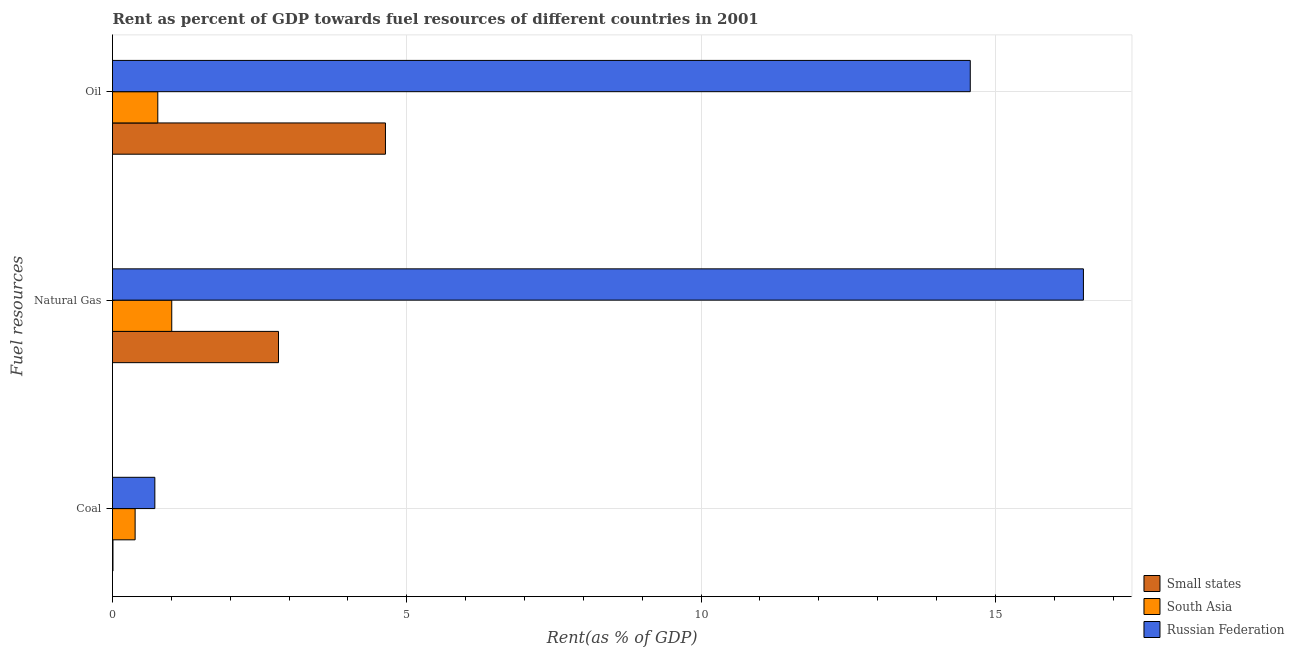How many groups of bars are there?
Make the answer very short. 3. How many bars are there on the 1st tick from the top?
Give a very brief answer. 3. What is the label of the 3rd group of bars from the top?
Provide a succinct answer. Coal. What is the rent towards natural gas in South Asia?
Ensure brevity in your answer.  1.01. Across all countries, what is the maximum rent towards natural gas?
Keep it short and to the point. 16.5. Across all countries, what is the minimum rent towards coal?
Keep it short and to the point. 0.01. In which country was the rent towards oil maximum?
Your answer should be compact. Russian Federation. In which country was the rent towards natural gas minimum?
Offer a terse response. South Asia. What is the total rent towards oil in the graph?
Your answer should be compact. 19.98. What is the difference between the rent towards coal in Small states and that in Russian Federation?
Offer a terse response. -0.71. What is the difference between the rent towards oil in South Asia and the rent towards coal in Russian Federation?
Make the answer very short. 0.05. What is the average rent towards coal per country?
Provide a short and direct response. 0.37. What is the difference between the rent towards natural gas and rent towards oil in Small states?
Provide a short and direct response. -1.82. What is the ratio of the rent towards natural gas in Small states to that in Russian Federation?
Make the answer very short. 0.17. Is the rent towards coal in South Asia less than that in Small states?
Keep it short and to the point. No. Is the difference between the rent towards natural gas in Small states and South Asia greater than the difference between the rent towards coal in Small states and South Asia?
Make the answer very short. Yes. What is the difference between the highest and the second highest rent towards coal?
Ensure brevity in your answer.  0.34. What is the difference between the highest and the lowest rent towards natural gas?
Your answer should be compact. 15.49. What does the 1st bar from the top in Coal represents?
Offer a terse response. Russian Federation. What does the 1st bar from the bottom in Oil represents?
Provide a short and direct response. Small states. Are the values on the major ticks of X-axis written in scientific E-notation?
Make the answer very short. No. Does the graph contain grids?
Keep it short and to the point. Yes. What is the title of the graph?
Keep it short and to the point. Rent as percent of GDP towards fuel resources of different countries in 2001. Does "Tonga" appear as one of the legend labels in the graph?
Your answer should be very brief. No. What is the label or title of the X-axis?
Keep it short and to the point. Rent(as % of GDP). What is the label or title of the Y-axis?
Offer a terse response. Fuel resources. What is the Rent(as % of GDP) in Small states in Coal?
Ensure brevity in your answer.  0.01. What is the Rent(as % of GDP) of South Asia in Coal?
Ensure brevity in your answer.  0.38. What is the Rent(as % of GDP) of Russian Federation in Coal?
Your answer should be compact. 0.72. What is the Rent(as % of GDP) in Small states in Natural Gas?
Make the answer very short. 2.82. What is the Rent(as % of GDP) of South Asia in Natural Gas?
Give a very brief answer. 1.01. What is the Rent(as % of GDP) of Russian Federation in Natural Gas?
Make the answer very short. 16.5. What is the Rent(as % of GDP) in Small states in Oil?
Your response must be concise. 4.64. What is the Rent(as % of GDP) of South Asia in Oil?
Offer a terse response. 0.77. What is the Rent(as % of GDP) in Russian Federation in Oil?
Your answer should be compact. 14.57. Across all Fuel resources, what is the maximum Rent(as % of GDP) of Small states?
Keep it short and to the point. 4.64. Across all Fuel resources, what is the maximum Rent(as % of GDP) in South Asia?
Give a very brief answer. 1.01. Across all Fuel resources, what is the maximum Rent(as % of GDP) of Russian Federation?
Keep it short and to the point. 16.5. Across all Fuel resources, what is the minimum Rent(as % of GDP) in Small states?
Provide a short and direct response. 0.01. Across all Fuel resources, what is the minimum Rent(as % of GDP) of South Asia?
Give a very brief answer. 0.38. Across all Fuel resources, what is the minimum Rent(as % of GDP) of Russian Federation?
Offer a very short reply. 0.72. What is the total Rent(as % of GDP) of Small states in the graph?
Give a very brief answer. 7.47. What is the total Rent(as % of GDP) of South Asia in the graph?
Your answer should be compact. 2.16. What is the total Rent(as % of GDP) in Russian Federation in the graph?
Offer a very short reply. 31.79. What is the difference between the Rent(as % of GDP) of Small states in Coal and that in Natural Gas?
Provide a succinct answer. -2.81. What is the difference between the Rent(as % of GDP) of South Asia in Coal and that in Natural Gas?
Provide a succinct answer. -0.62. What is the difference between the Rent(as % of GDP) of Russian Federation in Coal and that in Natural Gas?
Your answer should be very brief. -15.78. What is the difference between the Rent(as % of GDP) in Small states in Coal and that in Oil?
Keep it short and to the point. -4.63. What is the difference between the Rent(as % of GDP) of South Asia in Coal and that in Oil?
Provide a succinct answer. -0.39. What is the difference between the Rent(as % of GDP) in Russian Federation in Coal and that in Oil?
Your response must be concise. -13.86. What is the difference between the Rent(as % of GDP) in Small states in Natural Gas and that in Oil?
Ensure brevity in your answer.  -1.82. What is the difference between the Rent(as % of GDP) in South Asia in Natural Gas and that in Oil?
Provide a short and direct response. 0.24. What is the difference between the Rent(as % of GDP) in Russian Federation in Natural Gas and that in Oil?
Your response must be concise. 1.92. What is the difference between the Rent(as % of GDP) of Small states in Coal and the Rent(as % of GDP) of South Asia in Natural Gas?
Offer a very short reply. -1. What is the difference between the Rent(as % of GDP) in Small states in Coal and the Rent(as % of GDP) in Russian Federation in Natural Gas?
Your response must be concise. -16.49. What is the difference between the Rent(as % of GDP) in South Asia in Coal and the Rent(as % of GDP) in Russian Federation in Natural Gas?
Provide a short and direct response. -16.11. What is the difference between the Rent(as % of GDP) in Small states in Coal and the Rent(as % of GDP) in South Asia in Oil?
Give a very brief answer. -0.76. What is the difference between the Rent(as % of GDP) of Small states in Coal and the Rent(as % of GDP) of Russian Federation in Oil?
Your answer should be very brief. -14.57. What is the difference between the Rent(as % of GDP) of South Asia in Coal and the Rent(as % of GDP) of Russian Federation in Oil?
Provide a succinct answer. -14.19. What is the difference between the Rent(as % of GDP) in Small states in Natural Gas and the Rent(as % of GDP) in South Asia in Oil?
Give a very brief answer. 2.05. What is the difference between the Rent(as % of GDP) of Small states in Natural Gas and the Rent(as % of GDP) of Russian Federation in Oil?
Offer a very short reply. -11.75. What is the difference between the Rent(as % of GDP) in South Asia in Natural Gas and the Rent(as % of GDP) in Russian Federation in Oil?
Your answer should be compact. -13.57. What is the average Rent(as % of GDP) of Small states per Fuel resources?
Provide a succinct answer. 2.49. What is the average Rent(as % of GDP) of South Asia per Fuel resources?
Your answer should be very brief. 0.72. What is the average Rent(as % of GDP) in Russian Federation per Fuel resources?
Ensure brevity in your answer.  10.6. What is the difference between the Rent(as % of GDP) of Small states and Rent(as % of GDP) of South Asia in Coal?
Ensure brevity in your answer.  -0.38. What is the difference between the Rent(as % of GDP) in Small states and Rent(as % of GDP) in Russian Federation in Coal?
Give a very brief answer. -0.71. What is the difference between the Rent(as % of GDP) in South Asia and Rent(as % of GDP) in Russian Federation in Coal?
Ensure brevity in your answer.  -0.34. What is the difference between the Rent(as % of GDP) in Small states and Rent(as % of GDP) in South Asia in Natural Gas?
Keep it short and to the point. 1.81. What is the difference between the Rent(as % of GDP) of Small states and Rent(as % of GDP) of Russian Federation in Natural Gas?
Your answer should be very brief. -13.68. What is the difference between the Rent(as % of GDP) in South Asia and Rent(as % of GDP) in Russian Federation in Natural Gas?
Provide a short and direct response. -15.49. What is the difference between the Rent(as % of GDP) in Small states and Rent(as % of GDP) in South Asia in Oil?
Your answer should be compact. 3.87. What is the difference between the Rent(as % of GDP) of Small states and Rent(as % of GDP) of Russian Federation in Oil?
Offer a terse response. -9.94. What is the difference between the Rent(as % of GDP) of South Asia and Rent(as % of GDP) of Russian Federation in Oil?
Make the answer very short. -13.81. What is the ratio of the Rent(as % of GDP) in Small states in Coal to that in Natural Gas?
Your answer should be very brief. 0. What is the ratio of the Rent(as % of GDP) of South Asia in Coal to that in Natural Gas?
Keep it short and to the point. 0.38. What is the ratio of the Rent(as % of GDP) of Russian Federation in Coal to that in Natural Gas?
Provide a succinct answer. 0.04. What is the ratio of the Rent(as % of GDP) in Small states in Coal to that in Oil?
Give a very brief answer. 0. What is the ratio of the Rent(as % of GDP) of South Asia in Coal to that in Oil?
Give a very brief answer. 0.5. What is the ratio of the Rent(as % of GDP) of Russian Federation in Coal to that in Oil?
Make the answer very short. 0.05. What is the ratio of the Rent(as % of GDP) in Small states in Natural Gas to that in Oil?
Offer a very short reply. 0.61. What is the ratio of the Rent(as % of GDP) of South Asia in Natural Gas to that in Oil?
Offer a very short reply. 1.31. What is the ratio of the Rent(as % of GDP) of Russian Federation in Natural Gas to that in Oil?
Keep it short and to the point. 1.13. What is the difference between the highest and the second highest Rent(as % of GDP) in Small states?
Your answer should be very brief. 1.82. What is the difference between the highest and the second highest Rent(as % of GDP) of South Asia?
Your answer should be very brief. 0.24. What is the difference between the highest and the second highest Rent(as % of GDP) in Russian Federation?
Ensure brevity in your answer.  1.92. What is the difference between the highest and the lowest Rent(as % of GDP) in Small states?
Your answer should be compact. 4.63. What is the difference between the highest and the lowest Rent(as % of GDP) of South Asia?
Provide a short and direct response. 0.62. What is the difference between the highest and the lowest Rent(as % of GDP) in Russian Federation?
Offer a terse response. 15.78. 